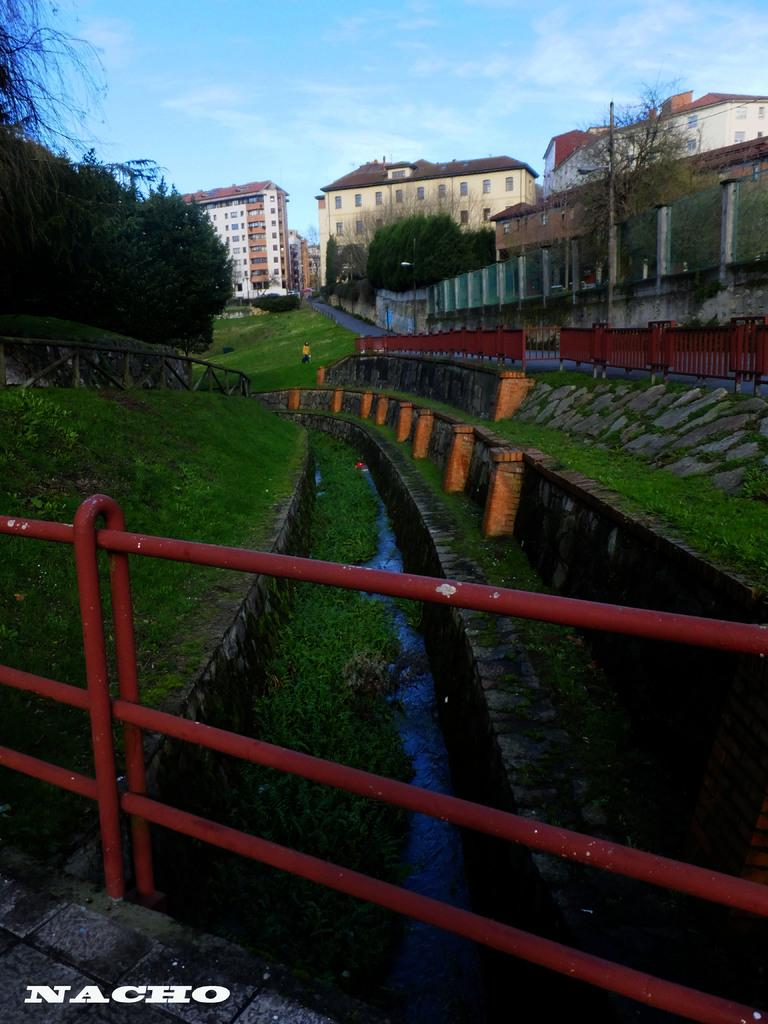What is located in the foreground of the image? There is a boundary in the foreground of the image. What type of vegetation can be seen in the image? There are trees in the image. What is the terrain like in the image? There is grassland in the image. What type of structures are present in the image? There are buildings in the image. What natural element is visible in the image? There is water visible in the image. What part of the environment is visible in the image? The sky is visible in the image. What additional information is provided at the bottom of the image? There is text at the bottom side of the image. What type of polish is being applied to the buildings in the image? There is no indication in the image that any polish is being applied to the buildings. Can you tell me how many patients are waiting in the hospital depicted in the image? There is no hospital present in the image, so it is not possible to determine the number of patients waiting. 